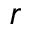Convert formula to latex. <formula><loc_0><loc_0><loc_500><loc_500>r</formula> 